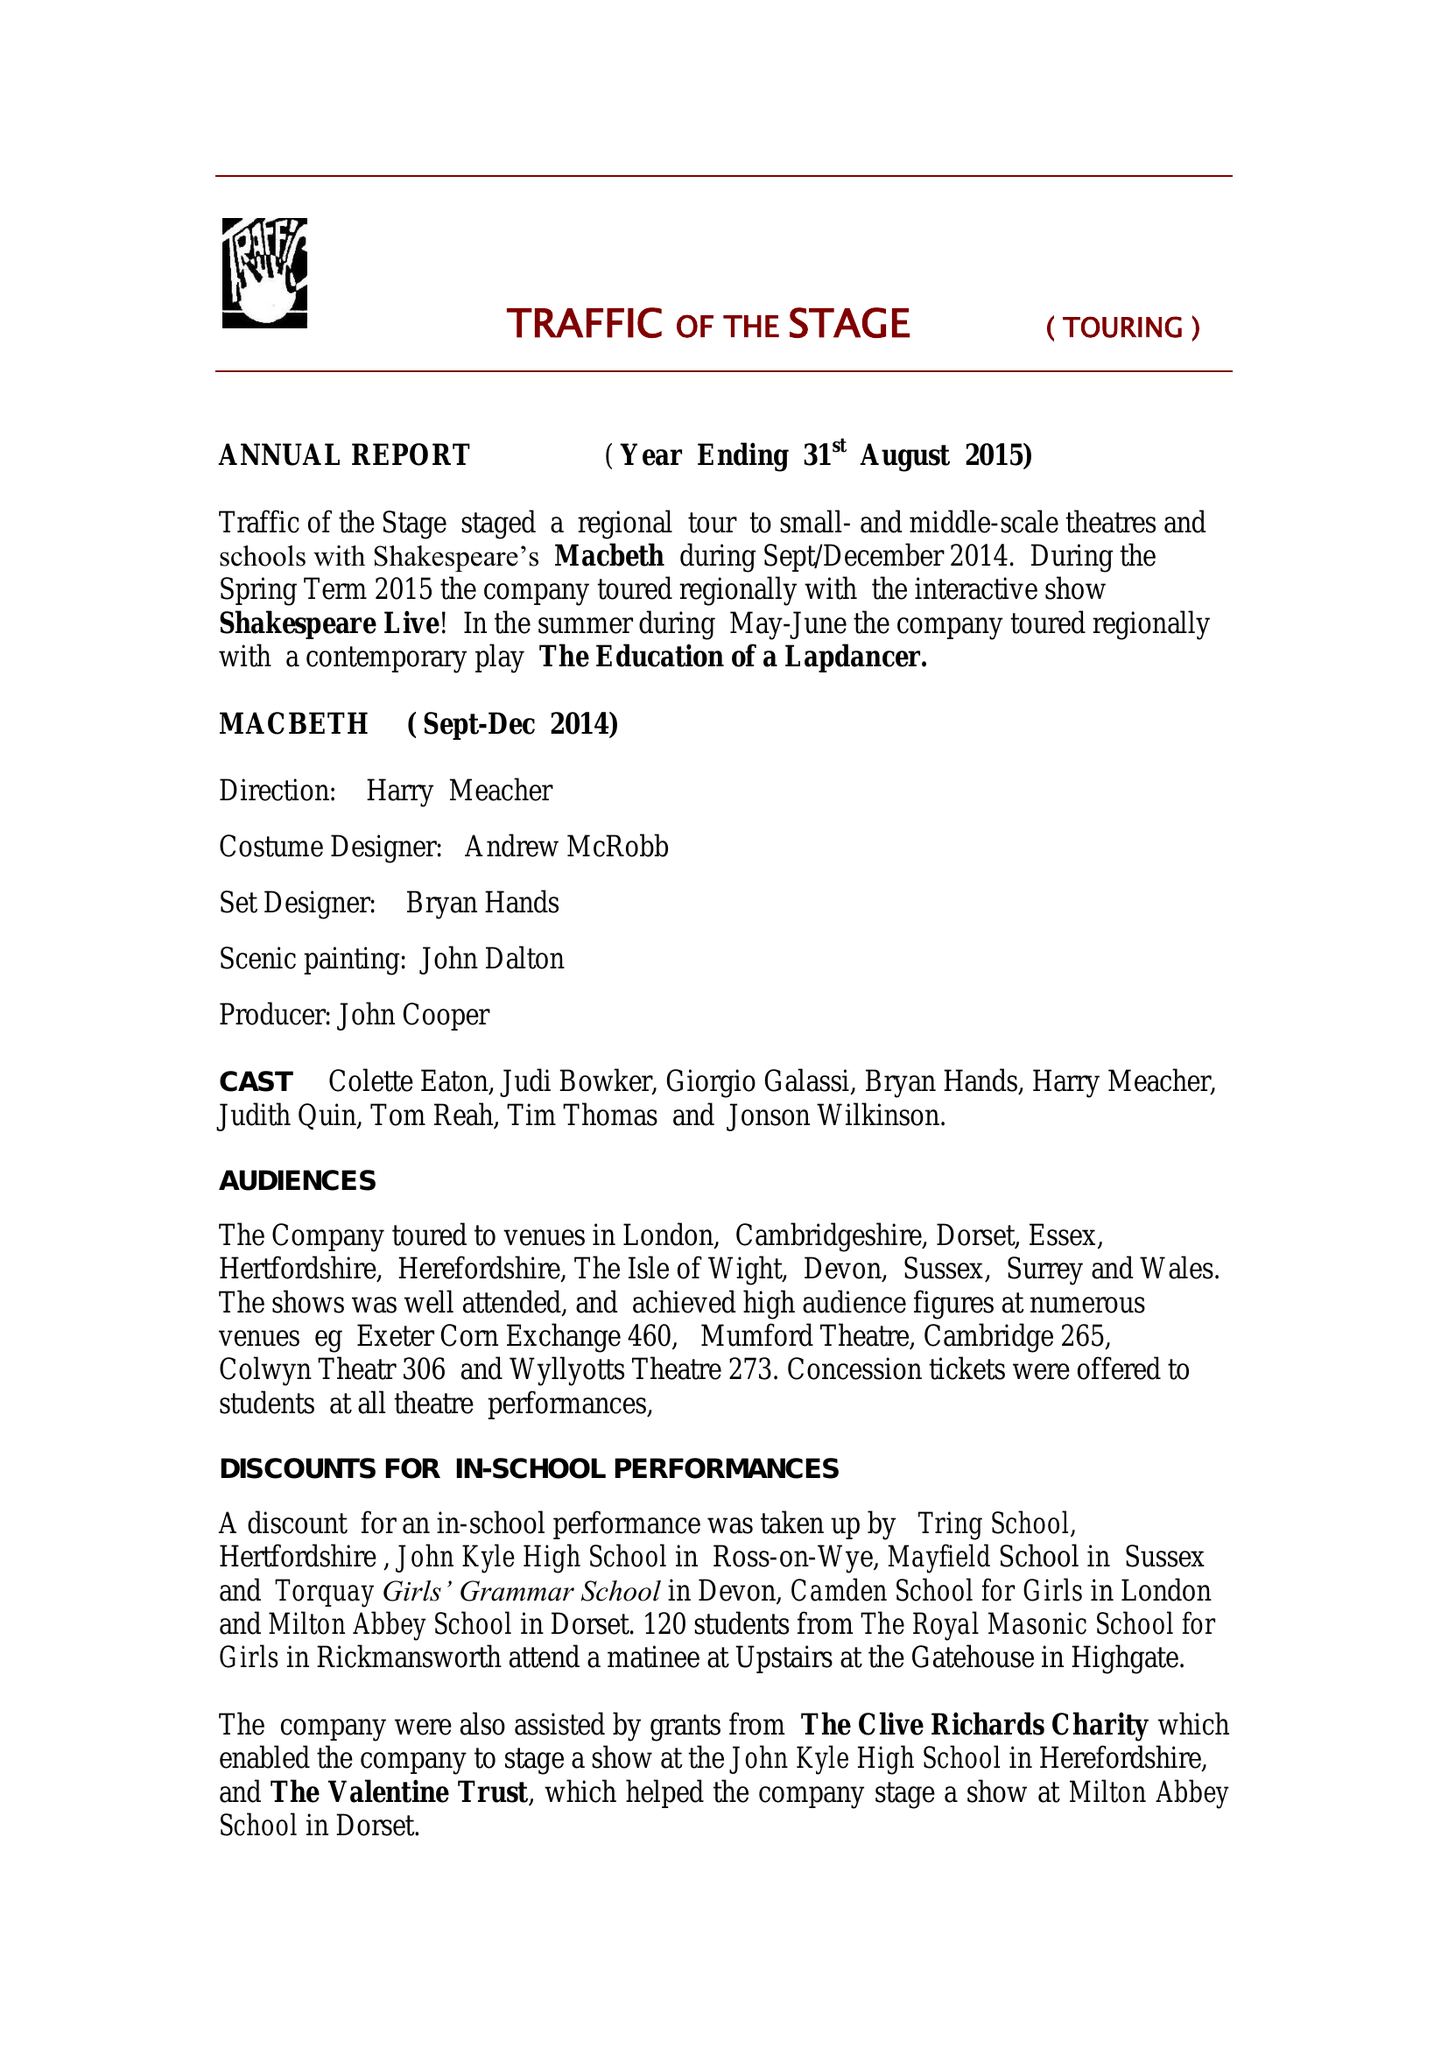What is the value for the report_date?
Answer the question using a single word or phrase. 2015-08-31 